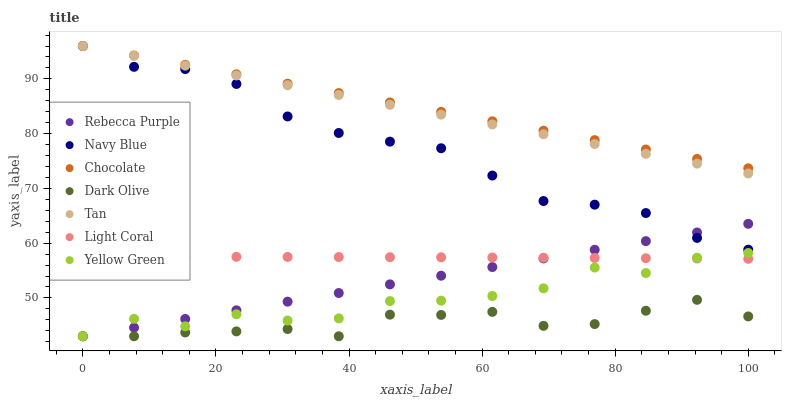Does Dark Olive have the minimum area under the curve?
Answer yes or no. Yes. Does Chocolate have the maximum area under the curve?
Answer yes or no. Yes. Does Navy Blue have the minimum area under the curve?
Answer yes or no. No. Does Navy Blue have the maximum area under the curve?
Answer yes or no. No. Is Rebecca Purple the smoothest?
Answer yes or no. Yes. Is Yellow Green the roughest?
Answer yes or no. Yes. Is Navy Blue the smoothest?
Answer yes or no. No. Is Navy Blue the roughest?
Answer yes or no. No. Does Yellow Green have the lowest value?
Answer yes or no. Yes. Does Navy Blue have the lowest value?
Answer yes or no. No. Does Tan have the highest value?
Answer yes or no. Yes. Does Dark Olive have the highest value?
Answer yes or no. No. Is Light Coral less than Navy Blue?
Answer yes or no. Yes. Is Navy Blue greater than Yellow Green?
Answer yes or no. Yes. Does Dark Olive intersect Yellow Green?
Answer yes or no. Yes. Is Dark Olive less than Yellow Green?
Answer yes or no. No. Is Dark Olive greater than Yellow Green?
Answer yes or no. No. Does Light Coral intersect Navy Blue?
Answer yes or no. No. 